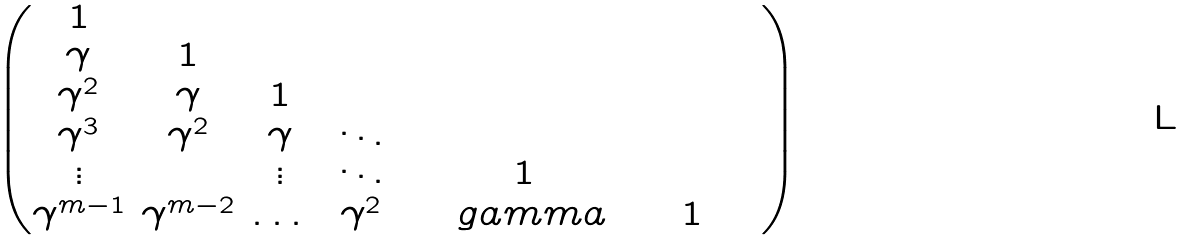Convert formula to latex. <formula><loc_0><loc_0><loc_500><loc_500>\begin{pmatrix} 1 & & & & & \\ \gamma & 1 & & & & \\ \gamma ^ { 2 } & \gamma & 1 & & & \\ \gamma ^ { 3 } & \gamma ^ { 2 } & \gamma & \ddots & & \\ \vdots & & \vdots & \ddots & 1 & \\ \gamma ^ { m - 1 } & \gamma ^ { m - 2 } & \dots & \ \gamma ^ { 2 } \ & \quad g a m m a \ \ & \ \ 1 \ \ \ \ \end{pmatrix}</formula> 